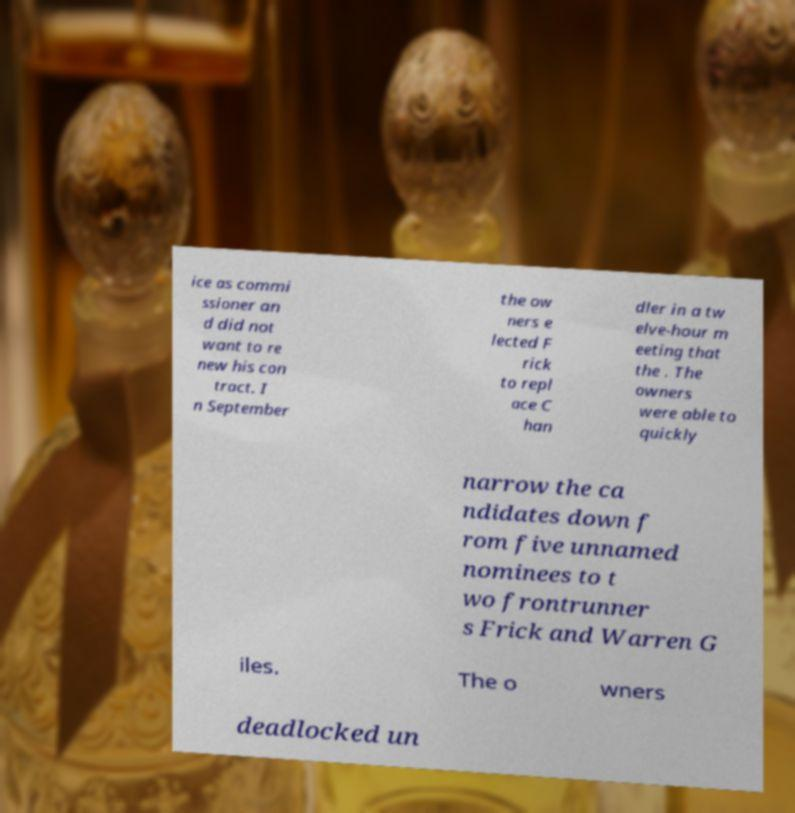Could you extract and type out the text from this image? ice as commi ssioner an d did not want to re new his con tract. I n September the ow ners e lected F rick to repl ace C han dler in a tw elve-hour m eeting that the . The owners were able to quickly narrow the ca ndidates down f rom five unnamed nominees to t wo frontrunner s Frick and Warren G iles. The o wners deadlocked un 